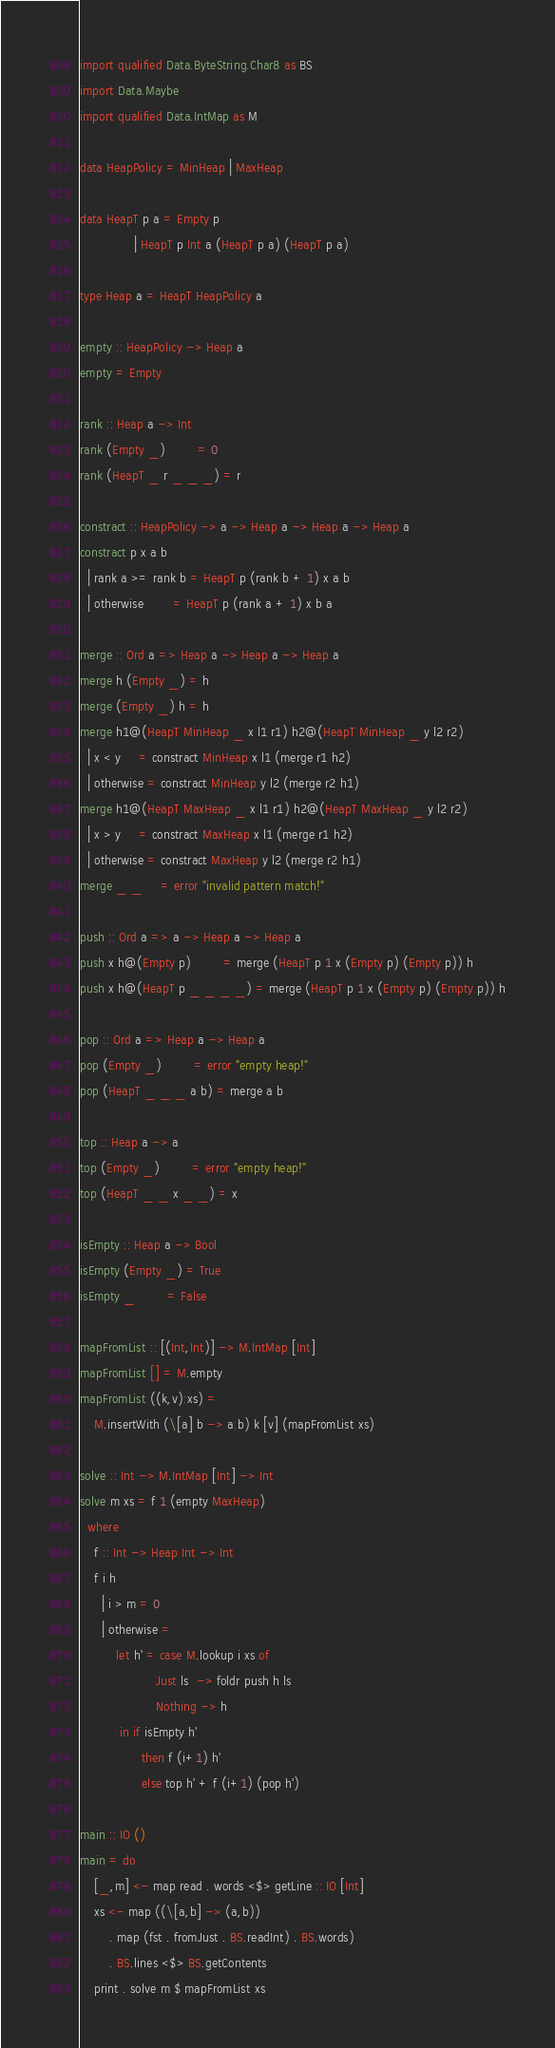<code> <loc_0><loc_0><loc_500><loc_500><_Haskell_>import qualified Data.ByteString.Char8 as BS
import Data.Maybe
import qualified Data.IntMap as M

data HeapPolicy = MinHeap | MaxHeap

data HeapT p a = Empty p
               | HeapT p Int a (HeapT p a) (HeapT p a)

type Heap a = HeapT HeapPolicy a

empty :: HeapPolicy -> Heap a
empty = Empty

rank :: Heap a -> Int
rank (Empty _)         = 0
rank (HeapT _ r _ _ _) = r

constract :: HeapPolicy -> a -> Heap a -> Heap a -> Heap a
constract p x a b
  | rank a >= rank b = HeapT p (rank b + 1) x a b
  | otherwise        = HeapT p (rank a + 1) x b a

merge :: Ord a => Heap a -> Heap a -> Heap a
merge h (Empty _) = h
merge (Empty _) h = h
merge h1@(HeapT MinHeap _ x l1 r1) h2@(HeapT MinHeap _ y l2 r2)
  | x < y     = constract MinHeap x l1 (merge r1 h2)
  | otherwise = constract MinHeap y l2 (merge r2 h1)
merge h1@(HeapT MaxHeap _ x l1 r1) h2@(HeapT MaxHeap _ y l2 r2)
  | x > y     = constract MaxHeap x l1 (merge r1 h2)
  | otherwise = constract MaxHeap y l2 (merge r2 h1)
merge _ _     = error "invalid pattern match!"

push :: Ord a => a -> Heap a -> Heap a
push x h@(Empty p)         = merge (HeapT p 1 x (Empty p) (Empty p)) h
push x h@(HeapT p _ _ _ _) = merge (HeapT p 1 x (Empty p) (Empty p)) h

pop :: Ord a => Heap a -> Heap a
pop (Empty _)         = error "empty heap!"
pop (HeapT _ _ _ a b) = merge a b

top :: Heap a -> a
top (Empty _)         = error "empty heap!"
top (HeapT _ _ x _ _) = x

isEmpty :: Heap a -> Bool
isEmpty (Empty _) = True
isEmpty _         = False

mapFromList :: [(Int,Int)] -> M.IntMap [Int]
mapFromList [] = M.empty
mapFromList ((k,v):xs) =
    M.insertWith (\[a] b -> a:b) k [v] (mapFromList xs)

solve :: Int -> M.IntMap [Int] -> Int
solve m xs = f 1 (empty MaxHeap)
  where
    f :: Int -> Heap Int -> Int
    f i h
      | i > m = 0
      | otherwise =
          let h' = case M.lookup i xs of
                     Just ls  -> foldr push h ls
                     Nothing -> h
           in if isEmpty h'
                 then f (i+1) h'
                 else top h' + f (i+1) (pop h')

main :: IO ()
main = do
    [_,m] <- map read . words <$> getLine :: IO [Int]
    xs <- map ((\[a,b] -> (a,b))
        . map (fst . fromJust . BS.readInt) . BS.words)
        . BS.lines <$> BS.getContents
    print . solve m $ mapFromList xs
</code> 